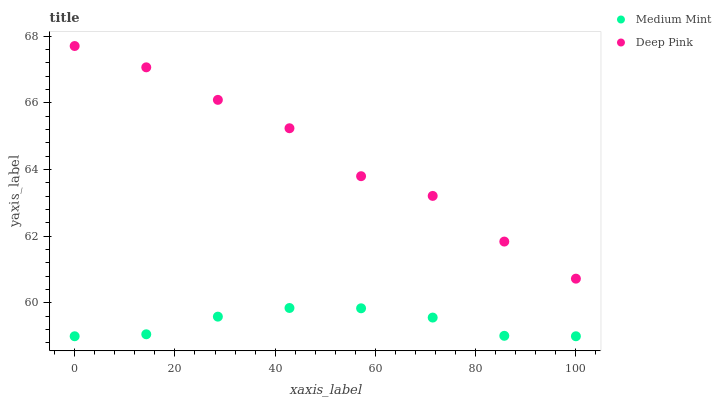Does Medium Mint have the minimum area under the curve?
Answer yes or no. Yes. Does Deep Pink have the maximum area under the curve?
Answer yes or no. Yes. Does Deep Pink have the minimum area under the curve?
Answer yes or no. No. Is Medium Mint the smoothest?
Answer yes or no. Yes. Is Deep Pink the roughest?
Answer yes or no. Yes. Is Deep Pink the smoothest?
Answer yes or no. No. Does Medium Mint have the lowest value?
Answer yes or no. Yes. Does Deep Pink have the lowest value?
Answer yes or no. No. Does Deep Pink have the highest value?
Answer yes or no. Yes. Is Medium Mint less than Deep Pink?
Answer yes or no. Yes. Is Deep Pink greater than Medium Mint?
Answer yes or no. Yes. Does Medium Mint intersect Deep Pink?
Answer yes or no. No. 